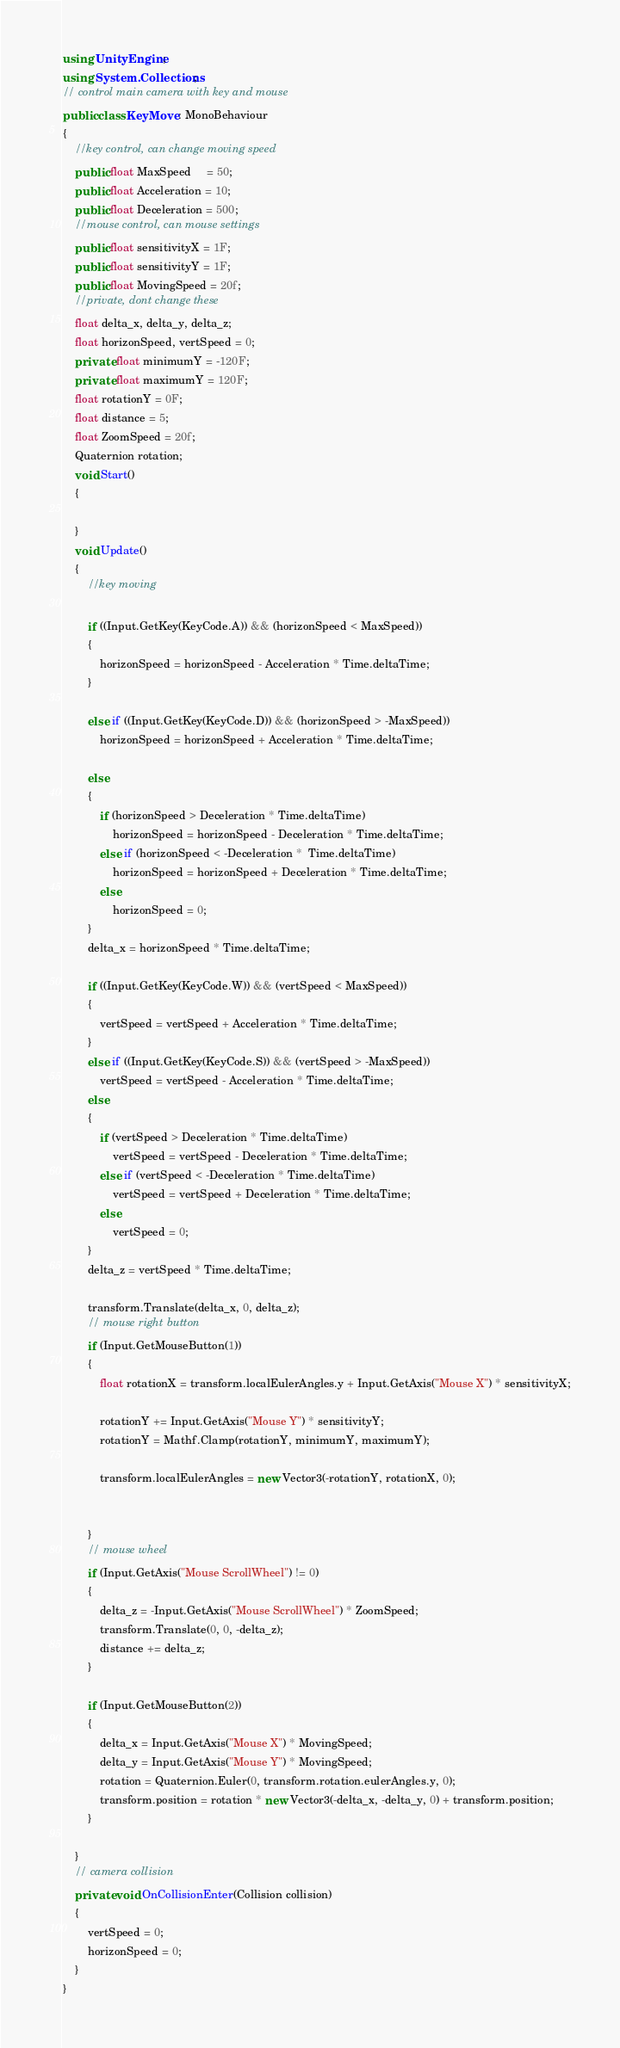Convert code to text. <code><loc_0><loc_0><loc_500><loc_500><_C#_>using UnityEngine;
using System.Collections;
// control main camera with key and mouse
public class KeyMove : MonoBehaviour
{
    //key control, can change moving speed
    public float MaxSpeed     = 50; 
    public float Acceleration = 10;
    public float Deceleration = 500;
    //mouse control, can mouse settings
    public float sensitivityX = 1F;        
    public float sensitivityY = 1F;
    public float MovingSpeed = 20f;
    //private, dont change these
    float delta_x, delta_y, delta_z;
    float horizonSpeed, vertSpeed = 0;
    private float minimumY = -120F;          
    private float maximumY = 120F;
    float rotationY = 0F; 
    float distance = 5;
    float ZoomSpeed = 20f;                 
    Quaternion rotation;
    void Start()
    {

    }
    void Update()
    {
        //key moving
        
        if ((Input.GetKey(KeyCode.A)) && (horizonSpeed < MaxSpeed))
        {
            horizonSpeed = horizonSpeed - Acceleration * Time.deltaTime;
        }
                
        else if ((Input.GetKey(KeyCode.D)) && (horizonSpeed > -MaxSpeed))
            horizonSpeed = horizonSpeed + Acceleration * Time.deltaTime;
        
        else
        {
            if (horizonSpeed > Deceleration * Time.deltaTime)
                horizonSpeed = horizonSpeed - Deceleration * Time.deltaTime;
            else if (horizonSpeed < -Deceleration *  Time.deltaTime)
                horizonSpeed = horizonSpeed + Deceleration * Time.deltaTime;
            else
                horizonSpeed = 0;
        }
        delta_x = horizonSpeed * Time.deltaTime;

        if ((Input.GetKey(KeyCode.W)) && (vertSpeed < MaxSpeed))
        {
            vertSpeed = vertSpeed + Acceleration * Time.deltaTime;
        }
        else if ((Input.GetKey(KeyCode.S)) && (vertSpeed > -MaxSpeed))
            vertSpeed = vertSpeed - Acceleration * Time.deltaTime;
        else
        {
            if (vertSpeed > Deceleration * Time.deltaTime)
                vertSpeed = vertSpeed - Deceleration * Time.deltaTime;
            else if (vertSpeed < -Deceleration * Time.deltaTime)
                vertSpeed = vertSpeed + Deceleration * Time.deltaTime;
            else
                vertSpeed = 0;
        }
        delta_z = vertSpeed * Time.deltaTime;

        transform.Translate(delta_x, 0, delta_z);
        // mouse right button
        if (Input.GetMouseButton(1))
        {
            float rotationX = transform.localEulerAngles.y + Input.GetAxis("Mouse X") * sensitivityX;

            rotationY += Input.GetAxis("Mouse Y") * sensitivityY;
            rotationY = Mathf.Clamp(rotationY, minimumY, maximumY);

            transform.localEulerAngles = new Vector3(-rotationY, rotationX, 0);


        }
        // mouse wheel
        if (Input.GetAxis("Mouse ScrollWheel") != 0)
        {
            delta_z = -Input.GetAxis("Mouse ScrollWheel") * ZoomSpeed;
            transform.Translate(0, 0, -delta_z);
            distance += delta_z;
        }
        
        if (Input.GetMouseButton(2))
        {
            delta_x = Input.GetAxis("Mouse X") * MovingSpeed;
            delta_y = Input.GetAxis("Mouse Y") * MovingSpeed;
            rotation = Quaternion.Euler(0, transform.rotation.eulerAngles.y, 0);
            transform.position = rotation * new Vector3(-delta_x, -delta_y, 0) + transform.position;
        }

    }
    // camera collision
    private void OnCollisionEnter(Collision collision)
    {
        vertSpeed = 0;
        horizonSpeed = 0;
    }
}</code> 